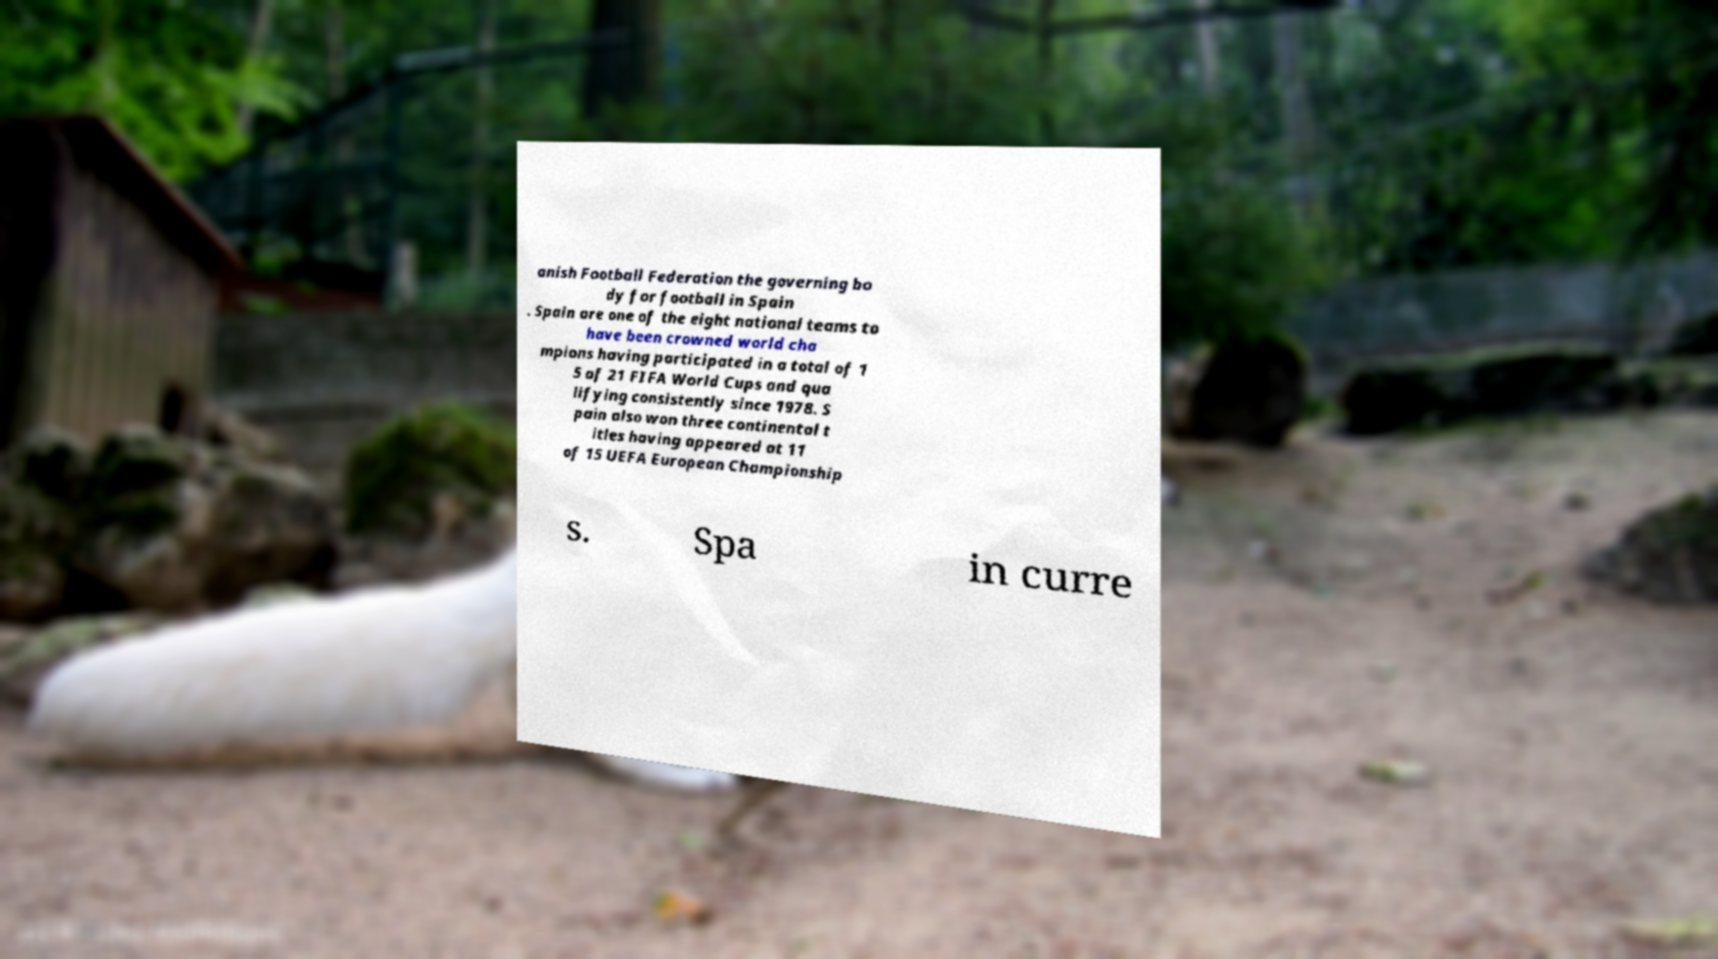I need the written content from this picture converted into text. Can you do that? anish Football Federation the governing bo dy for football in Spain . Spain are one of the eight national teams to have been crowned world cha mpions having participated in a total of 1 5 of 21 FIFA World Cups and qua lifying consistently since 1978. S pain also won three continental t itles having appeared at 11 of 15 UEFA European Championship s. Spa in curre 